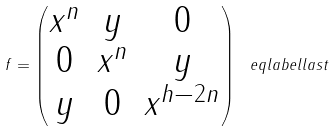<formula> <loc_0><loc_0><loc_500><loc_500>f = \begin{pmatrix} x ^ { n } & y & 0 \\ 0 & x ^ { n } & y \\ y & 0 & x ^ { h - 2 n } \end{pmatrix} \ e q l a b e l { l a s t }</formula> 